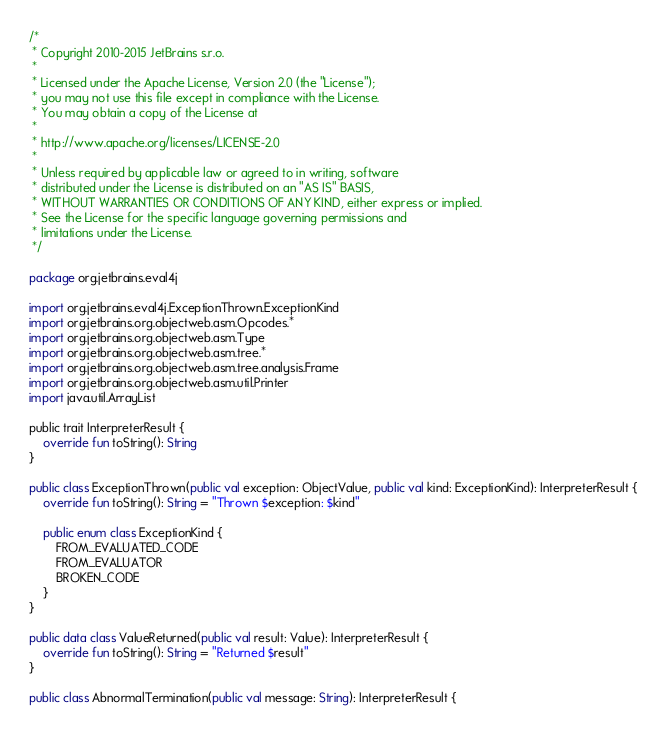Convert code to text. <code><loc_0><loc_0><loc_500><loc_500><_Kotlin_>/*
 * Copyright 2010-2015 JetBrains s.r.o.
 *
 * Licensed under the Apache License, Version 2.0 (the "License");
 * you may not use this file except in compliance with the License.
 * You may obtain a copy of the License at
 *
 * http://www.apache.org/licenses/LICENSE-2.0
 *
 * Unless required by applicable law or agreed to in writing, software
 * distributed under the License is distributed on an "AS IS" BASIS,
 * WITHOUT WARRANTIES OR CONDITIONS OF ANY KIND, either express or implied.
 * See the License for the specific language governing permissions and
 * limitations under the License.
 */

package org.jetbrains.eval4j

import org.jetbrains.eval4j.ExceptionThrown.ExceptionKind
import org.jetbrains.org.objectweb.asm.Opcodes.*
import org.jetbrains.org.objectweb.asm.Type
import org.jetbrains.org.objectweb.asm.tree.*
import org.jetbrains.org.objectweb.asm.tree.analysis.Frame
import org.jetbrains.org.objectweb.asm.util.Printer
import java.util.ArrayList

public trait InterpreterResult {
    override fun toString(): String
}

public class ExceptionThrown(public val exception: ObjectValue, public val kind: ExceptionKind): InterpreterResult {
    override fun toString(): String = "Thrown $exception: $kind"

    public enum class ExceptionKind {
        FROM_EVALUATED_CODE
        FROM_EVALUATOR
        BROKEN_CODE
    }
}

public data class ValueReturned(public val result: Value): InterpreterResult {
    override fun toString(): String = "Returned $result"
}

public class AbnormalTermination(public val message: String): InterpreterResult {</code> 